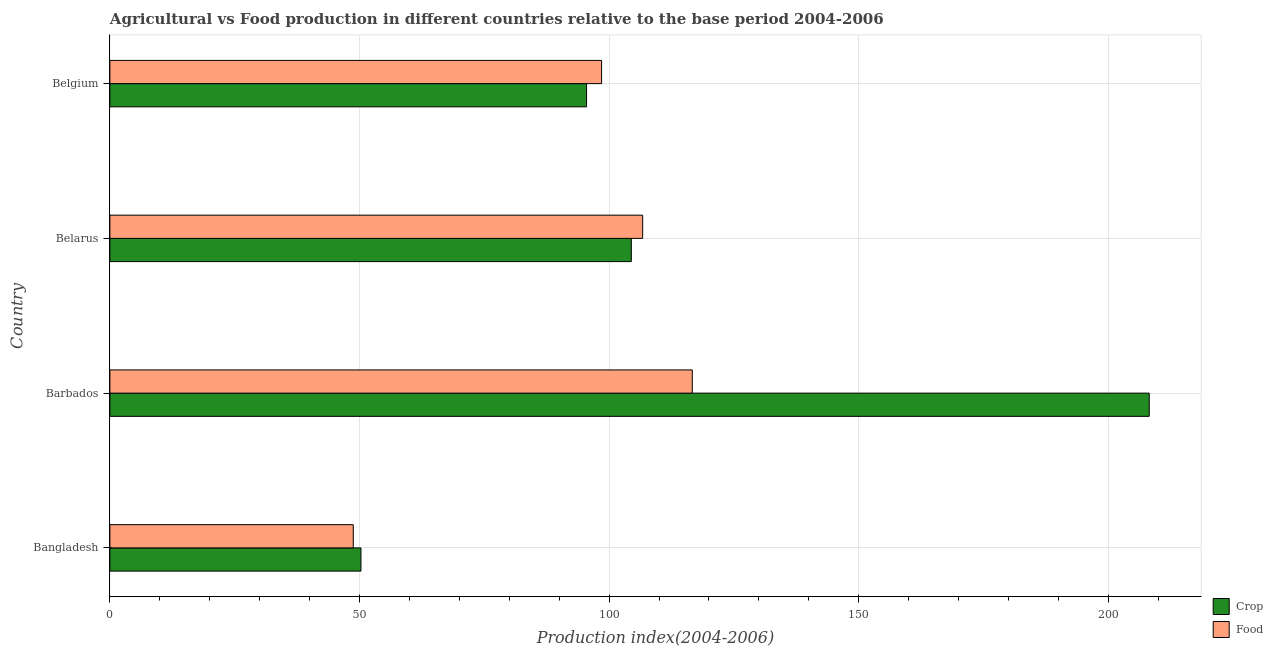How many different coloured bars are there?
Offer a very short reply. 2. Are the number of bars per tick equal to the number of legend labels?
Ensure brevity in your answer.  Yes. Are the number of bars on each tick of the Y-axis equal?
Your answer should be very brief. Yes. What is the label of the 2nd group of bars from the top?
Your answer should be very brief. Belarus. What is the crop production index in Belarus?
Your answer should be very brief. 104.45. Across all countries, what is the maximum food production index?
Give a very brief answer. 116.66. Across all countries, what is the minimum crop production index?
Your answer should be compact. 50.29. In which country was the food production index maximum?
Your answer should be compact. Barbados. What is the total food production index in the graph?
Make the answer very short. 370.62. What is the difference between the food production index in Belarus and that in Belgium?
Make the answer very short. 8.23. What is the difference between the food production index in Barbados and the crop production index in Belgium?
Give a very brief answer. 21.18. What is the average food production index per country?
Keep it short and to the point. 92.66. What is the difference between the crop production index and food production index in Belarus?
Make the answer very short. -2.27. What is the ratio of the crop production index in Bangladesh to that in Belarus?
Your response must be concise. 0.48. Is the difference between the crop production index in Barbados and Belarus greater than the difference between the food production index in Barbados and Belarus?
Provide a short and direct response. Yes. What is the difference between the highest and the second highest food production index?
Provide a short and direct response. 9.94. What is the difference between the highest and the lowest crop production index?
Offer a terse response. 157.9. What does the 1st bar from the top in Bangladesh represents?
Keep it short and to the point. Food. What does the 1st bar from the bottom in Barbados represents?
Your response must be concise. Crop. Are all the bars in the graph horizontal?
Provide a succinct answer. Yes. Are the values on the major ticks of X-axis written in scientific E-notation?
Ensure brevity in your answer.  No. What is the title of the graph?
Offer a very short reply. Agricultural vs Food production in different countries relative to the base period 2004-2006. What is the label or title of the X-axis?
Keep it short and to the point. Production index(2004-2006). What is the Production index(2004-2006) of Crop in Bangladesh?
Your answer should be compact. 50.29. What is the Production index(2004-2006) of Food in Bangladesh?
Offer a terse response. 48.75. What is the Production index(2004-2006) in Crop in Barbados?
Offer a terse response. 208.19. What is the Production index(2004-2006) of Food in Barbados?
Provide a succinct answer. 116.66. What is the Production index(2004-2006) in Crop in Belarus?
Your answer should be very brief. 104.45. What is the Production index(2004-2006) in Food in Belarus?
Make the answer very short. 106.72. What is the Production index(2004-2006) of Crop in Belgium?
Provide a short and direct response. 95.48. What is the Production index(2004-2006) in Food in Belgium?
Your response must be concise. 98.49. Across all countries, what is the maximum Production index(2004-2006) in Crop?
Offer a terse response. 208.19. Across all countries, what is the maximum Production index(2004-2006) in Food?
Your response must be concise. 116.66. Across all countries, what is the minimum Production index(2004-2006) of Crop?
Offer a very short reply. 50.29. Across all countries, what is the minimum Production index(2004-2006) of Food?
Keep it short and to the point. 48.75. What is the total Production index(2004-2006) of Crop in the graph?
Ensure brevity in your answer.  458.41. What is the total Production index(2004-2006) of Food in the graph?
Provide a short and direct response. 370.62. What is the difference between the Production index(2004-2006) of Crop in Bangladesh and that in Barbados?
Make the answer very short. -157.9. What is the difference between the Production index(2004-2006) in Food in Bangladesh and that in Barbados?
Your response must be concise. -67.91. What is the difference between the Production index(2004-2006) in Crop in Bangladesh and that in Belarus?
Offer a very short reply. -54.16. What is the difference between the Production index(2004-2006) in Food in Bangladesh and that in Belarus?
Offer a very short reply. -57.97. What is the difference between the Production index(2004-2006) of Crop in Bangladesh and that in Belgium?
Ensure brevity in your answer.  -45.19. What is the difference between the Production index(2004-2006) of Food in Bangladesh and that in Belgium?
Your answer should be compact. -49.74. What is the difference between the Production index(2004-2006) of Crop in Barbados and that in Belarus?
Provide a short and direct response. 103.74. What is the difference between the Production index(2004-2006) of Food in Barbados and that in Belarus?
Keep it short and to the point. 9.94. What is the difference between the Production index(2004-2006) of Crop in Barbados and that in Belgium?
Your answer should be very brief. 112.71. What is the difference between the Production index(2004-2006) of Food in Barbados and that in Belgium?
Keep it short and to the point. 18.17. What is the difference between the Production index(2004-2006) of Crop in Belarus and that in Belgium?
Provide a succinct answer. 8.97. What is the difference between the Production index(2004-2006) in Food in Belarus and that in Belgium?
Your answer should be very brief. 8.23. What is the difference between the Production index(2004-2006) of Crop in Bangladesh and the Production index(2004-2006) of Food in Barbados?
Ensure brevity in your answer.  -66.37. What is the difference between the Production index(2004-2006) in Crop in Bangladesh and the Production index(2004-2006) in Food in Belarus?
Make the answer very short. -56.43. What is the difference between the Production index(2004-2006) of Crop in Bangladesh and the Production index(2004-2006) of Food in Belgium?
Ensure brevity in your answer.  -48.2. What is the difference between the Production index(2004-2006) in Crop in Barbados and the Production index(2004-2006) in Food in Belarus?
Offer a very short reply. 101.47. What is the difference between the Production index(2004-2006) in Crop in Barbados and the Production index(2004-2006) in Food in Belgium?
Offer a terse response. 109.7. What is the difference between the Production index(2004-2006) of Crop in Belarus and the Production index(2004-2006) of Food in Belgium?
Your response must be concise. 5.96. What is the average Production index(2004-2006) of Crop per country?
Provide a succinct answer. 114.6. What is the average Production index(2004-2006) in Food per country?
Your answer should be compact. 92.66. What is the difference between the Production index(2004-2006) of Crop and Production index(2004-2006) of Food in Bangladesh?
Provide a succinct answer. 1.54. What is the difference between the Production index(2004-2006) in Crop and Production index(2004-2006) in Food in Barbados?
Provide a short and direct response. 91.53. What is the difference between the Production index(2004-2006) in Crop and Production index(2004-2006) in Food in Belarus?
Offer a terse response. -2.27. What is the difference between the Production index(2004-2006) of Crop and Production index(2004-2006) of Food in Belgium?
Your answer should be compact. -3.01. What is the ratio of the Production index(2004-2006) in Crop in Bangladesh to that in Barbados?
Ensure brevity in your answer.  0.24. What is the ratio of the Production index(2004-2006) of Food in Bangladesh to that in Barbados?
Your response must be concise. 0.42. What is the ratio of the Production index(2004-2006) in Crop in Bangladesh to that in Belarus?
Provide a short and direct response. 0.48. What is the ratio of the Production index(2004-2006) in Food in Bangladesh to that in Belarus?
Provide a succinct answer. 0.46. What is the ratio of the Production index(2004-2006) of Crop in Bangladesh to that in Belgium?
Make the answer very short. 0.53. What is the ratio of the Production index(2004-2006) of Food in Bangladesh to that in Belgium?
Your answer should be compact. 0.49. What is the ratio of the Production index(2004-2006) in Crop in Barbados to that in Belarus?
Offer a terse response. 1.99. What is the ratio of the Production index(2004-2006) in Food in Barbados to that in Belarus?
Offer a very short reply. 1.09. What is the ratio of the Production index(2004-2006) of Crop in Barbados to that in Belgium?
Make the answer very short. 2.18. What is the ratio of the Production index(2004-2006) in Food in Barbados to that in Belgium?
Your answer should be very brief. 1.18. What is the ratio of the Production index(2004-2006) in Crop in Belarus to that in Belgium?
Your answer should be very brief. 1.09. What is the ratio of the Production index(2004-2006) of Food in Belarus to that in Belgium?
Keep it short and to the point. 1.08. What is the difference between the highest and the second highest Production index(2004-2006) of Crop?
Offer a very short reply. 103.74. What is the difference between the highest and the second highest Production index(2004-2006) in Food?
Offer a terse response. 9.94. What is the difference between the highest and the lowest Production index(2004-2006) in Crop?
Provide a succinct answer. 157.9. What is the difference between the highest and the lowest Production index(2004-2006) of Food?
Your answer should be very brief. 67.91. 